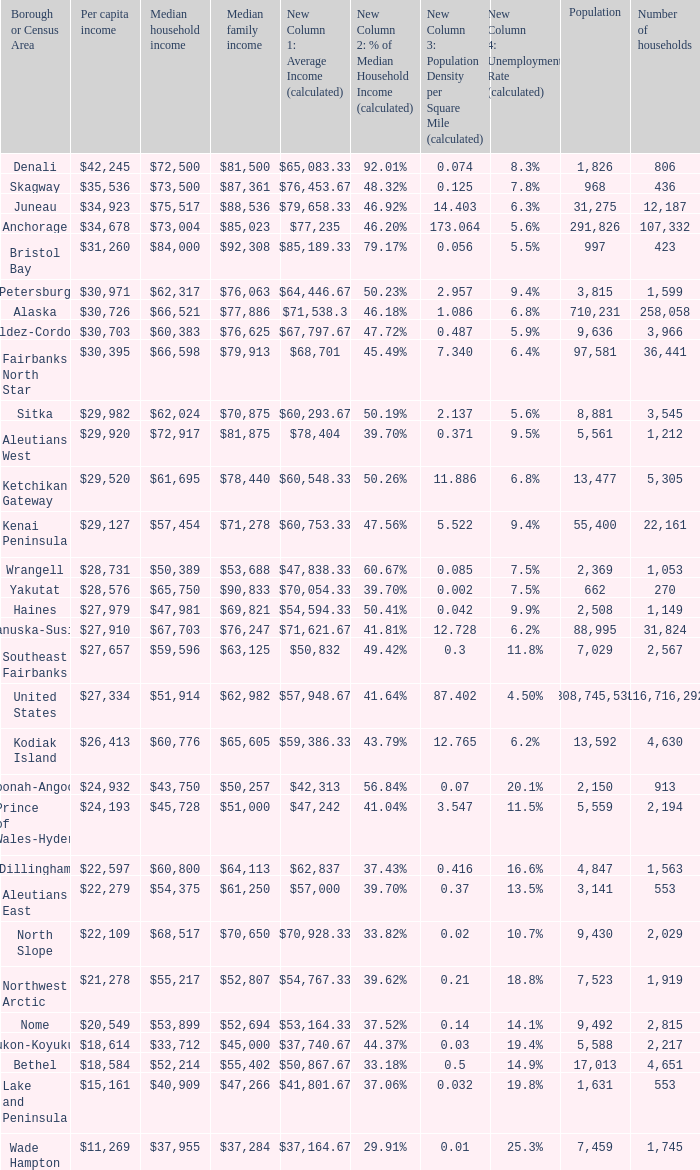What is the population of the area with a median family income of $71,278? 1.0. 